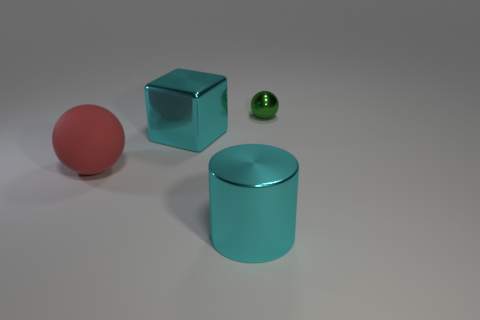Add 2 small objects. How many objects exist? 6 Subtract all blocks. How many objects are left? 3 Add 4 big red matte things. How many big red matte things are left? 5 Add 4 big purple shiny blocks. How many big purple shiny blocks exist? 4 Subtract 0 blue cylinders. How many objects are left? 4 Subtract all matte objects. Subtract all tiny spheres. How many objects are left? 2 